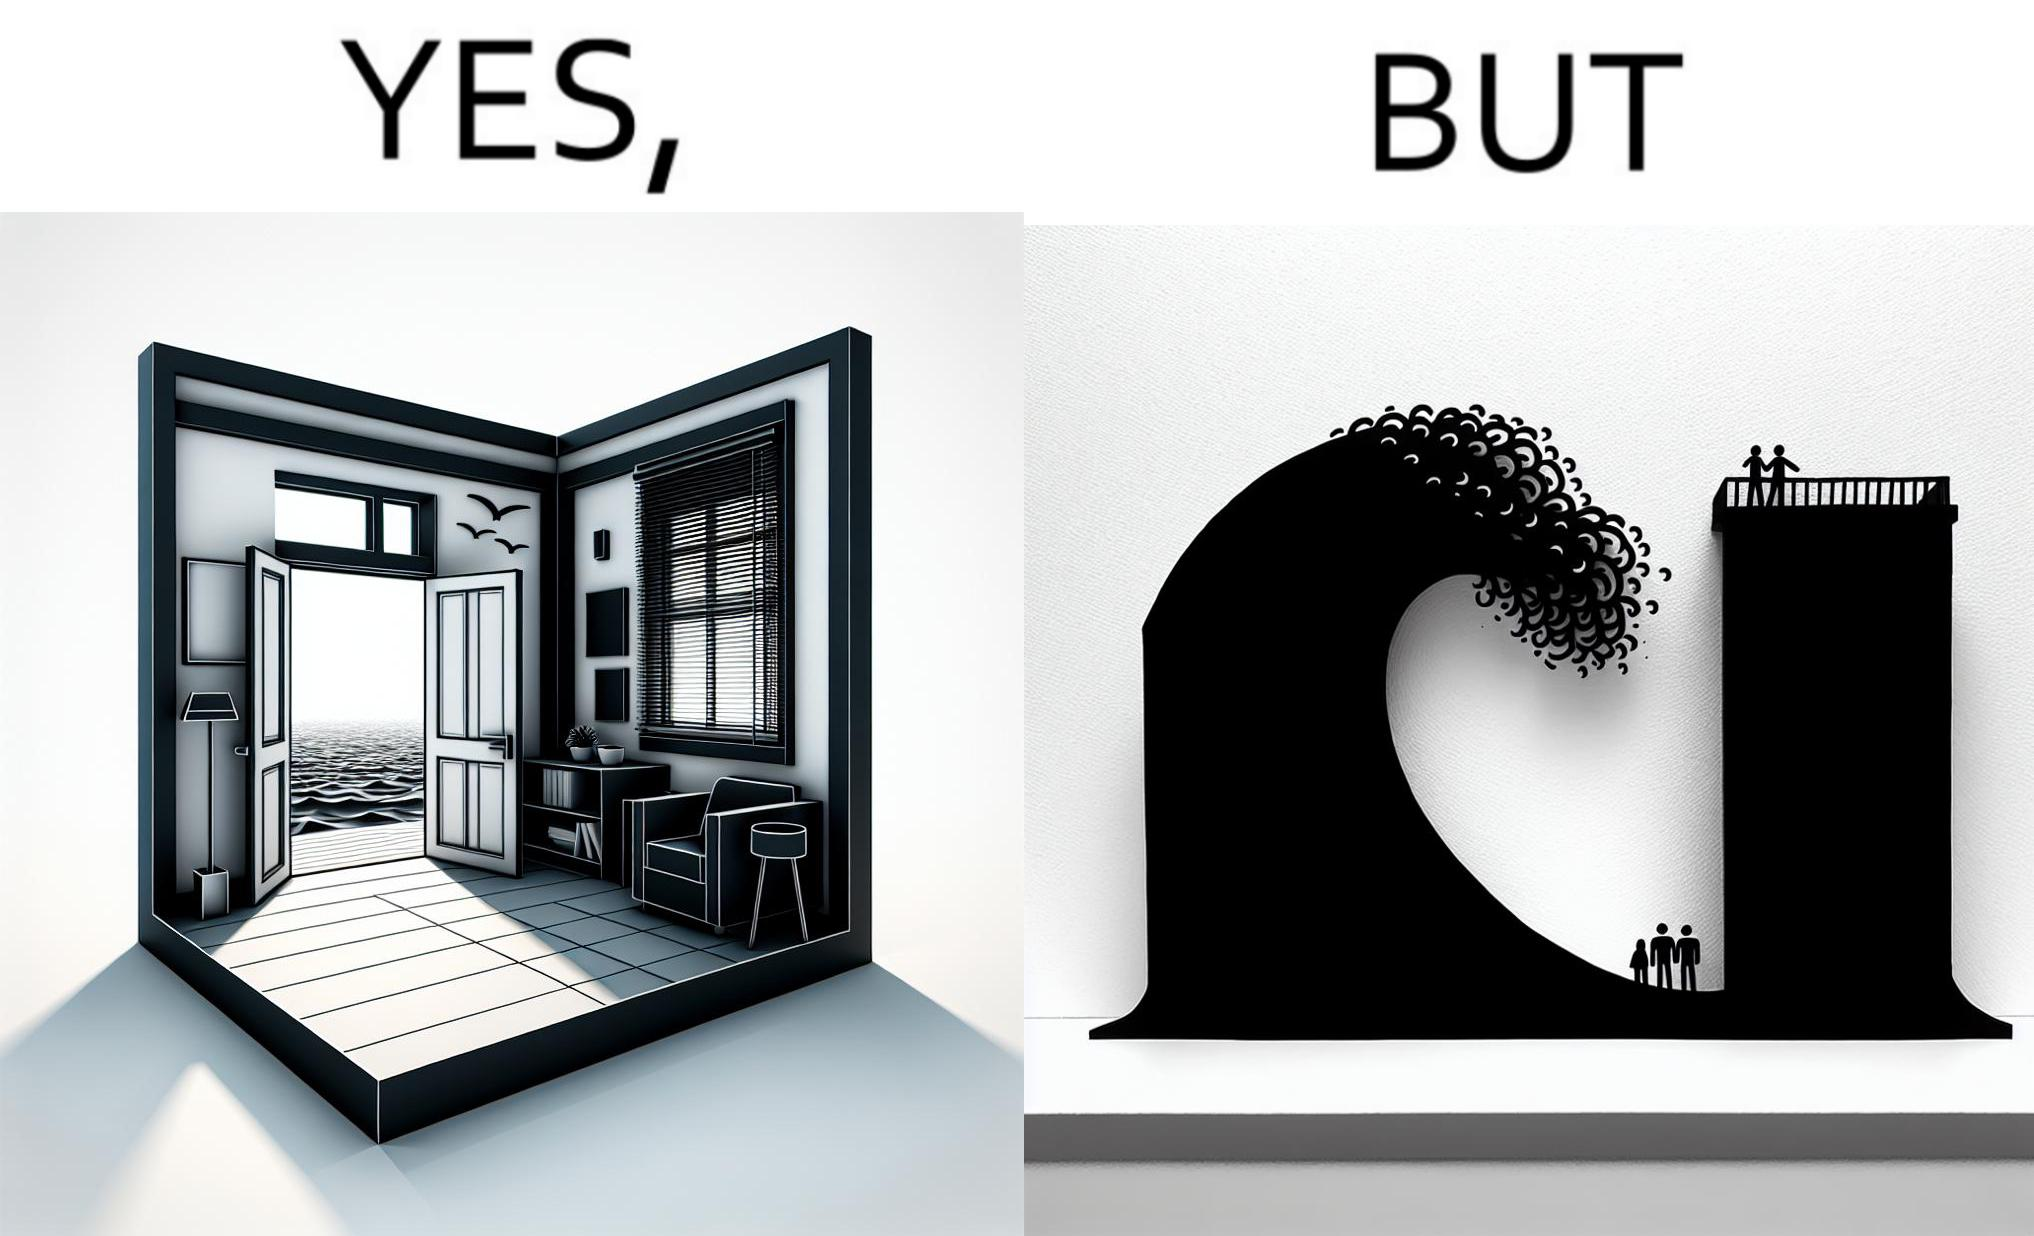Explain why this image is satirical. The same sea which gives us a relaxation on a normal day can pose a danger to us sometimes like during a tsunami 